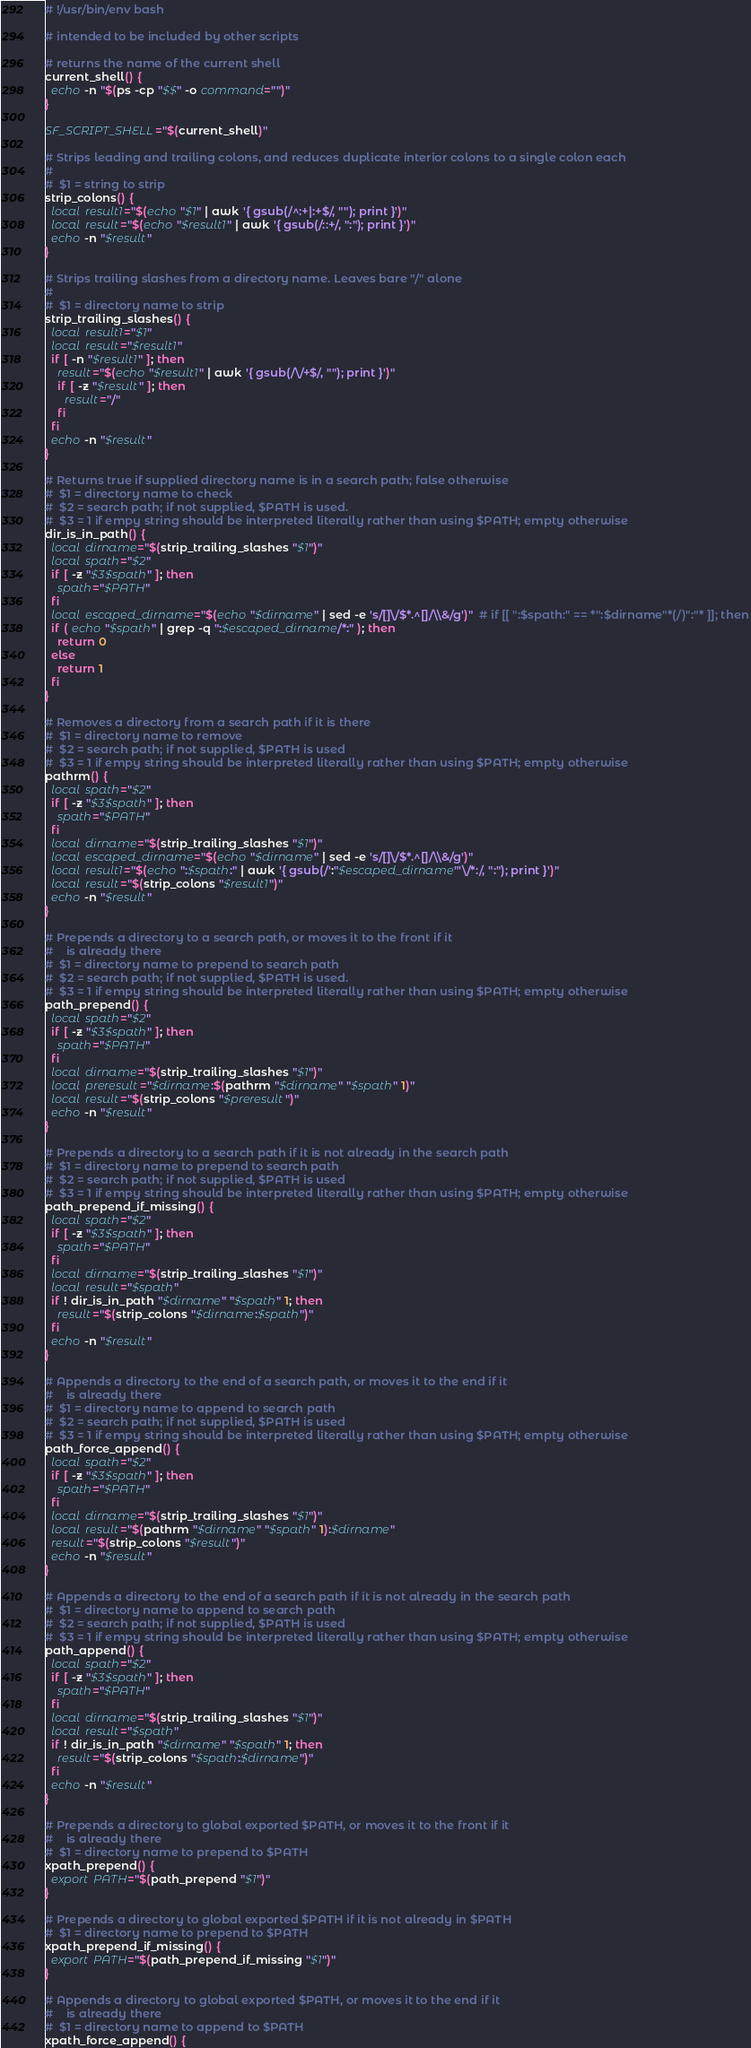Convert code to text. <code><loc_0><loc_0><loc_500><loc_500><_Bash_># !/usr/bin/env bash

# intended to be included by other scripts

# returns the name of the current shell
current_shell() {
  echo -n "$(ps -cp "$$" -o command="")"
}

SF_SCRIPT_SHELL="$(current_shell)"

# Strips leading and trailing colons, and reduces duplicate interior colons to a single colon each
#
#  $1 = string to strip
strip_colons() {
  local result1="$(echo "$1" | awk '{ gsub(/^:+|:+$/, ""); print }')"
  local result="$(echo "$result1" | awk '{ gsub(/::+/, ":"); print }')"
  echo -n "$result"
}

# Strips trailing slashes from a directory name. Leaves bare "/" alone
#
#  $1 = directory name to strip
strip_trailing_slashes() {
  local result1="$1"
  local result="$result1"
  if [ -n "$result1" ]; then
    result="$(echo "$result1" | awk '{ gsub(/\/+$/, ""); print }')"
    if [ -z "$result" ]; then
      result="/"
    fi
  fi
  echo -n "$result"
}

# Returns true if supplied directory name is in a search path; false otherwise
#  $1 = directory name to check
#  $2 = search path; if not supplied, $PATH is used.
#  $3 = 1 if empy string should be interpreted literally rather than using $PATH; empty otherwise
dir_is_in_path() {
  local dirname="$(strip_trailing_slashes "$1")"
  local spath="$2"  
  if [ -z "$3$spath" ]; then
    spath="$PATH"
  fi
  local escaped_dirname="$(echo "$dirname" | sed -e 's/[]\/$*.^[]/\\&/g')"  # if [[ ":$spath:" == *":$dirname"*(/)":"* ]]; then
  if ( echo "$spath" | grep -q ":$escaped_dirname/*:" ); then
    return 0
  else
    return 1
  fi
}

# Removes a directory from a search path if it is there
#  $1 = directory name to remove
#  $2 = search path; if not supplied, $PATH is used
#  $3 = 1 if empy string should be interpreted literally rather than using $PATH; empty otherwise
pathrm() {
  local spath="$2"
  if [ -z "$3$spath" ]; then
    spath="$PATH"
  fi
  local dirname="$(strip_trailing_slashes "$1")"
  local escaped_dirname="$(echo "$dirname" | sed -e 's/[]\/$*.^[]/\\&/g')"
  local result1="$(echo ":$spath:" | awk '{ gsub(/':"$escaped_dirname"'\/*:/, ":"); print }')"
  local result="$(strip_colons "$result1")"
  echo -n "$result"
}

# Prepends a directory to a search path, or moves it to the front if it
#    is already there
#  $1 = directory name to prepend to search path
#  $2 = search path; if not supplied, $PATH is used. 
#  $3 = 1 if empy string should be interpreted literally rather than using $PATH; empty otherwise
path_prepend() {
  local spath="$2"
  if [ -z "$3$spath" ]; then
    spath="$PATH"
  fi
  local dirname="$(strip_trailing_slashes "$1")"
  local preresult="$dirname:$(pathrm "$dirname" "$spath" 1)"
  local result="$(strip_colons "$preresult")"
  echo -n "$result"
}

# Prepends a directory to a search path if it is not already in the search path
#  $1 = directory name to prepend to search path
#  $2 = search path; if not supplied, $PATH is used
#  $3 = 1 if empy string should be interpreted literally rather than using $PATH; empty otherwise
path_prepend_if_missing() {
  local spath="$2"
  if [ -z "$3$spath" ]; then
    spath="$PATH"
  fi
  local dirname="$(strip_trailing_slashes "$1")"
  local result="$spath"
  if ! dir_is_in_path "$dirname" "$spath" 1; then
    result="$(strip_colons "$dirname:$spath")"
  fi
  echo -n "$result"
}

# Appends a directory to the end of a search path, or moves it to the end if it
#    is already there
#  $1 = directory name to append to search path
#  $2 = search path; if not supplied, $PATH is used
#  $3 = 1 if empy string should be interpreted literally rather than using $PATH; empty otherwise
path_force_append() {
  local spath="$2"
  if [ -z "$3$spath" ]; then
    spath="$PATH"
  fi
  local dirname="$(strip_trailing_slashes "$1")"
  local result="$(pathrm "$dirname" "$spath" 1):$dirname"
  result="$(strip_colons "$result")"
  echo -n "$result"
}

# Appends a directory to the end of a search path if it is not already in the search path
#  $1 = directory name to append to search path
#  $2 = search path; if not supplied, $PATH is used
#  $3 = 1 if empy string should be interpreted literally rather than using $PATH; empty otherwise
path_append() {
  local spath="$2"
  if [ -z "$3$spath" ]; then
    spath="$PATH"
  fi
  local dirname="$(strip_trailing_slashes "$1")"
  local result="$spath"
  if ! dir_is_in_path "$dirname" "$spath" 1; then
    result="$(strip_colons "$spath:$dirname")"
  fi
  echo -n "$result"
}

# Prepends a directory to global exported $PATH, or moves it to the front if it
#    is already there
#  $1 = directory name to prepend to $PATH
xpath_prepend() {
  export PATH="$(path_prepend "$1")"
}

# Prepends a directory to global exported $PATH if it is not already in $PATH
#  $1 = directory name to prepend to $PATH
xpath_prepend_if_missing() {
  export PATH="$(path_prepend_if_missing "$1")"
}

# Appends a directory to global exported $PATH, or moves it to the end if it
#    is already there
#  $1 = directory name to append to $PATH
xpath_force_append() {</code> 